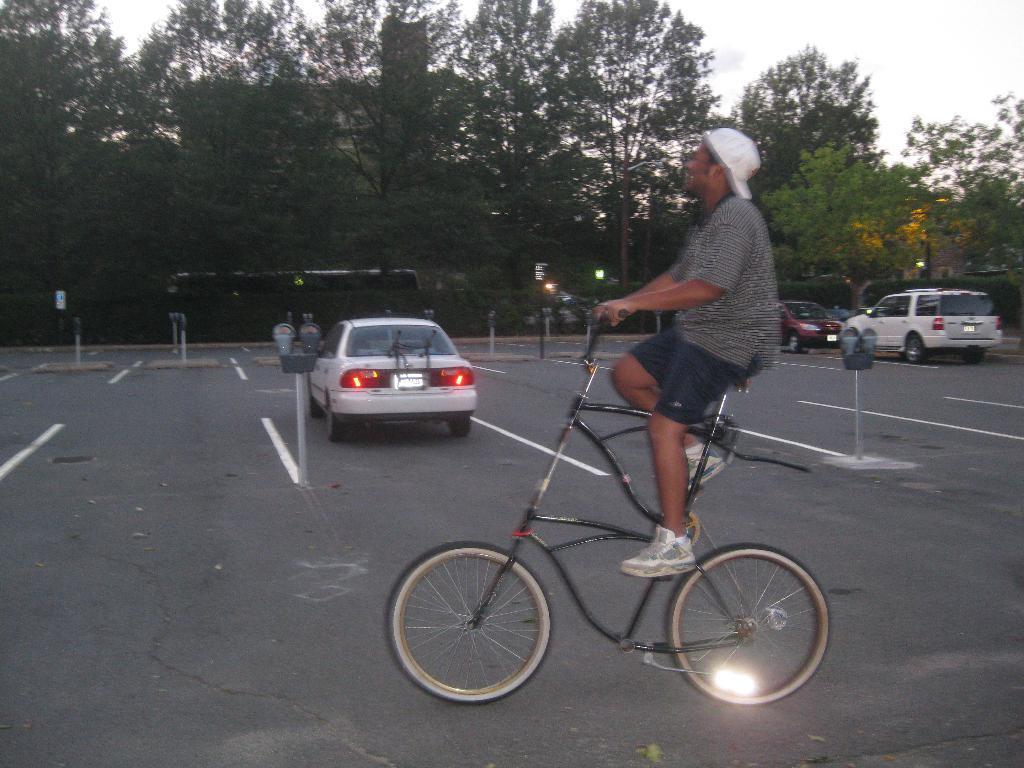In one or two sentences, can you explain what this image depicts? In this image a person is riding on a bicycle is wearing a shoes, cap. There are few vehicles on the road. At the background there are few trees and sky 